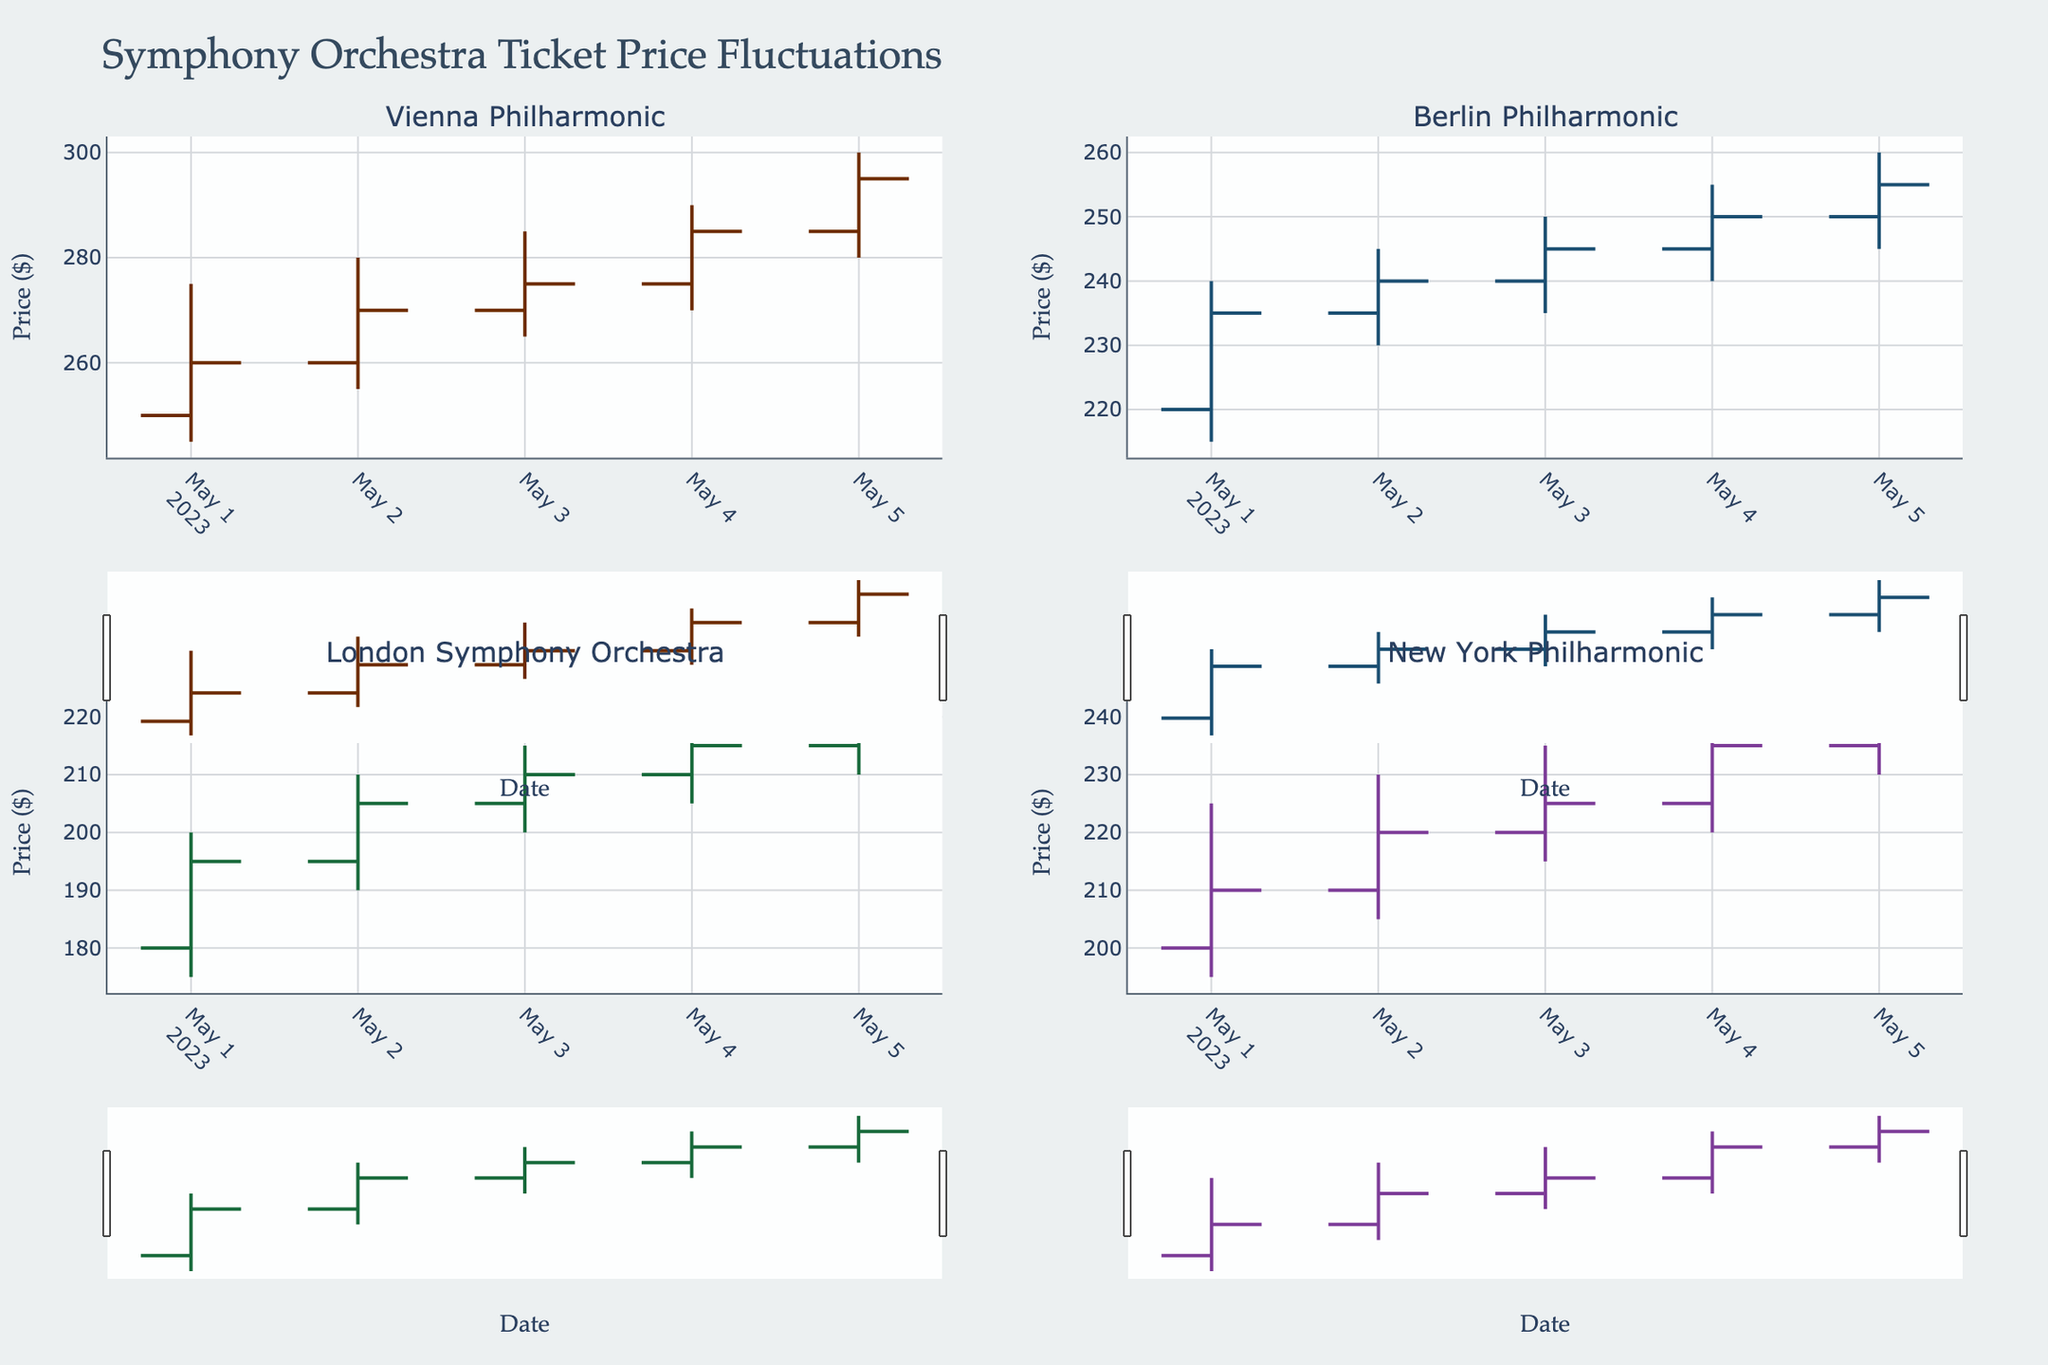What's the title of the figure? The title of the figure is displayed at the top of the plot.
Answer: Symphony Orchestra Ticket Price Fluctuations What are the date ranges displayed on the x-axis? The x-axis shows dates ranging from 2023-05-01 to 2023-05-05.
Answer: 2023-05-01 to 2023-05-05 Which symphony orchestra had the highest close price on 2023-05-05? To find this, check the OHLC plot on 2023-05-05 for each orchestra and identify the highest closing price. Vienna Philharmonic shows the highest close price of $295 on that date.
Answer: Vienna Philharmonic On which date did the Vienna Philharmonic have its highest high price? Review the high prices for Vienna Philharmonic and identify the date with the maximum value. The highest high price is $300, found on 2023-05-05.
Answer: 2023-05-05 Compare the open prices of the Berlin Philharmonic on 2023-05-02 and 2023-05-04. Which is higher? Identify the open prices of the Berlin Philharmonic for both dates. The open price on 2023-05-02 is $235, and on 2023-05-04 it is $245. Thus, the 2023-05-04 open price is higher.
Answer: 2023-05-04 What was the price range (high minus low) for the London Symphony Orchestra on 2023-05-03? Find the high and low prices for the London Symphony Orchestra on 2023-05-03. The high is $215 and the low is $200. The range is 215 - 200 = $15.
Answer: $15 Which orchestra had the lowest opening price on 2023-05-01? Check all opening prices on 2023-05-01. The lowest opening price is $180 by the London Symphony Orchestra.
Answer: London Symphony Orchestra By how much did the closing price of the New York Philharmonic increase from 2023-05-01 to 2023-05-05? Determine the closing prices for the New York Philharmonic on these dates: $210 (2023-05-01) and $240 (2023-05-05). The increase is 240 - 210 = $30.
Answer: $30 On 2023-05-04, did the Vienna Philharmonic's closing price exceed its opening price? Compare the Vienna Philharmonic's close price of $285 and open price of $275 on 2023-05-04. Yes, the close price exceeds the open price by $10.
Answer: Yes 